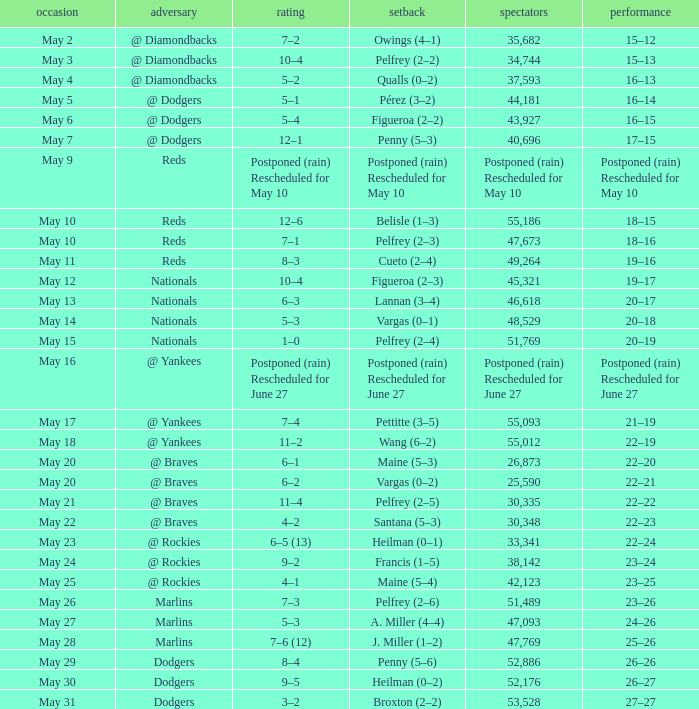What score was involved in the 22-20 record? 6–1. 